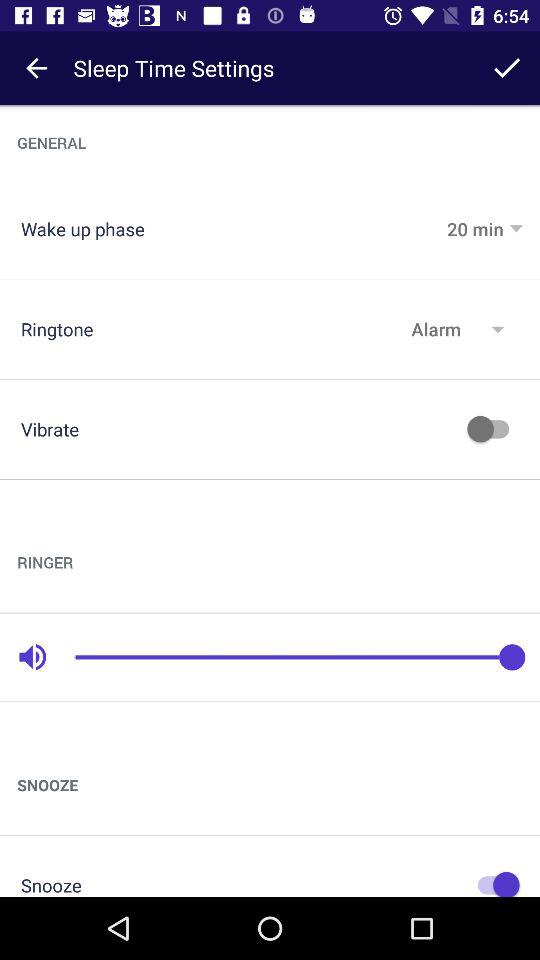What is the status of the "Snooze"? The status is "on". 